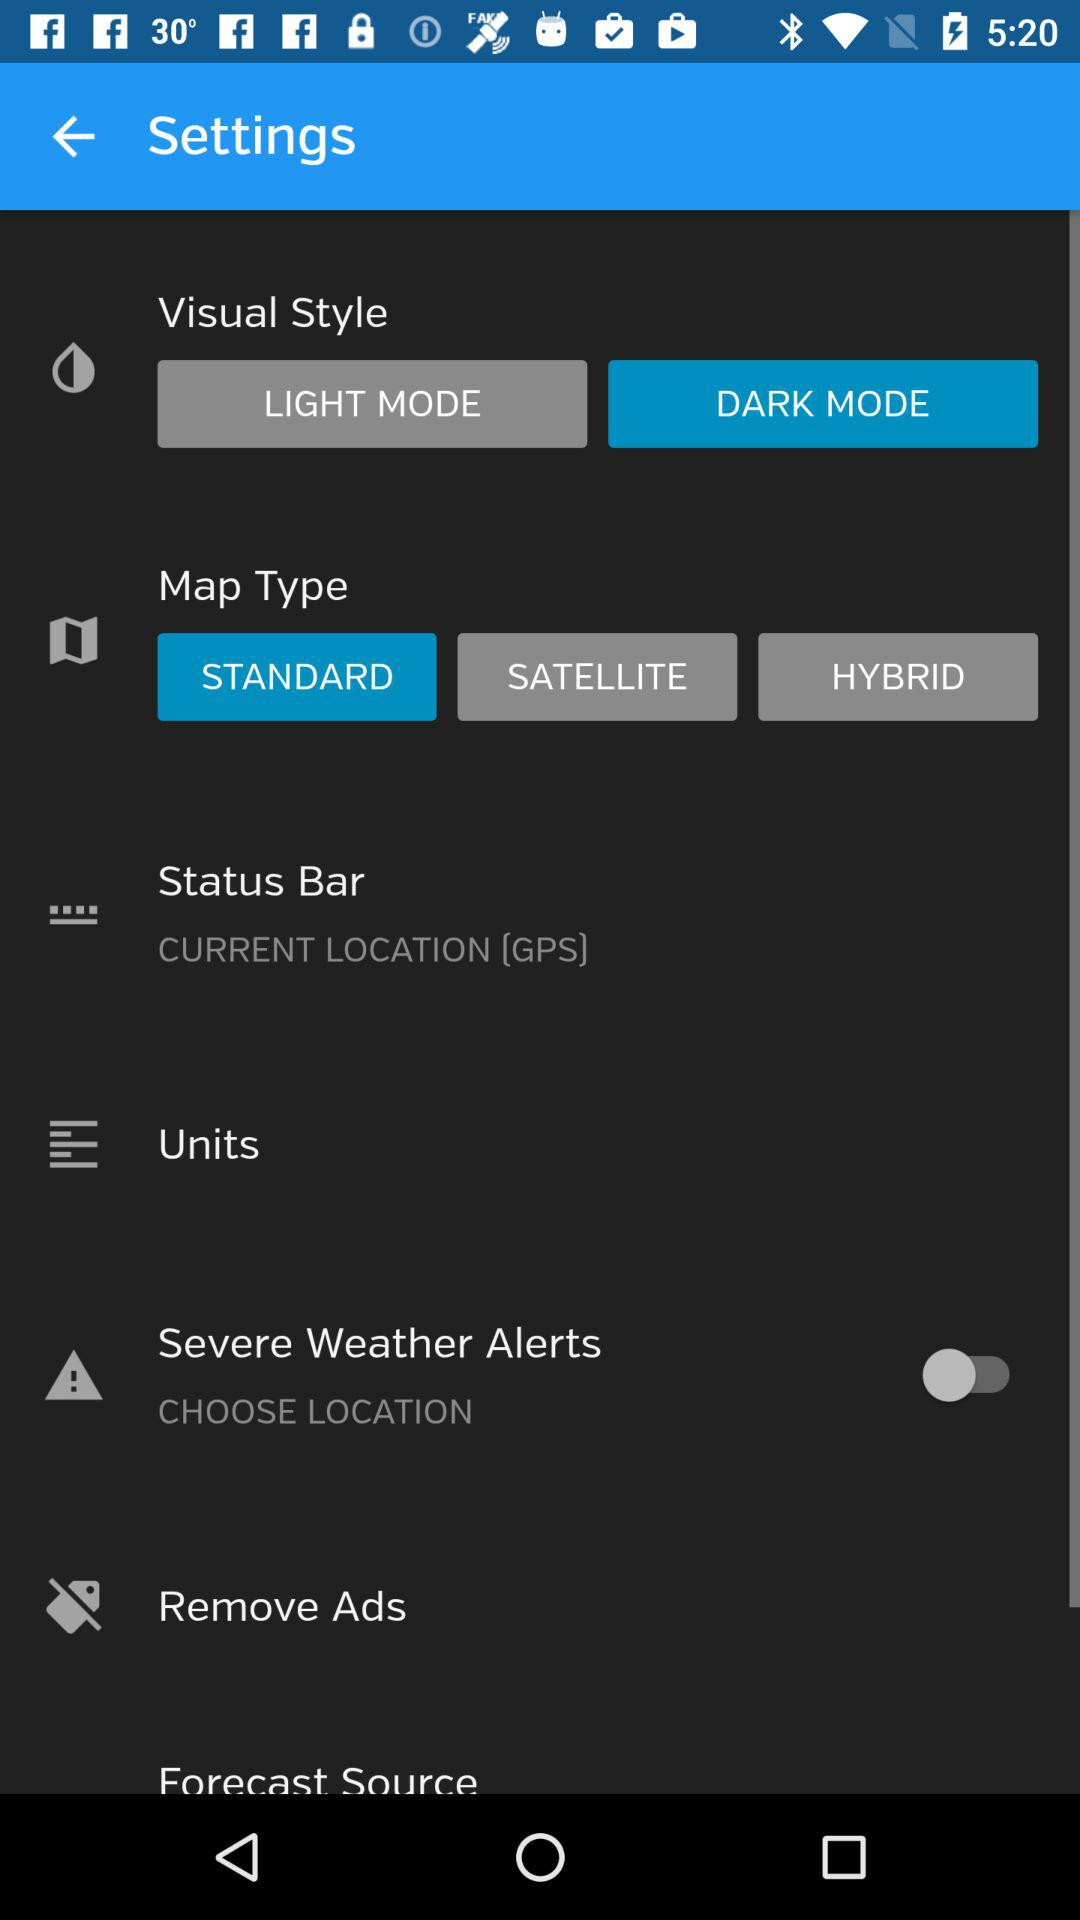Which visual style has been selected? The visual style that has been selected is "DARK MODE". 